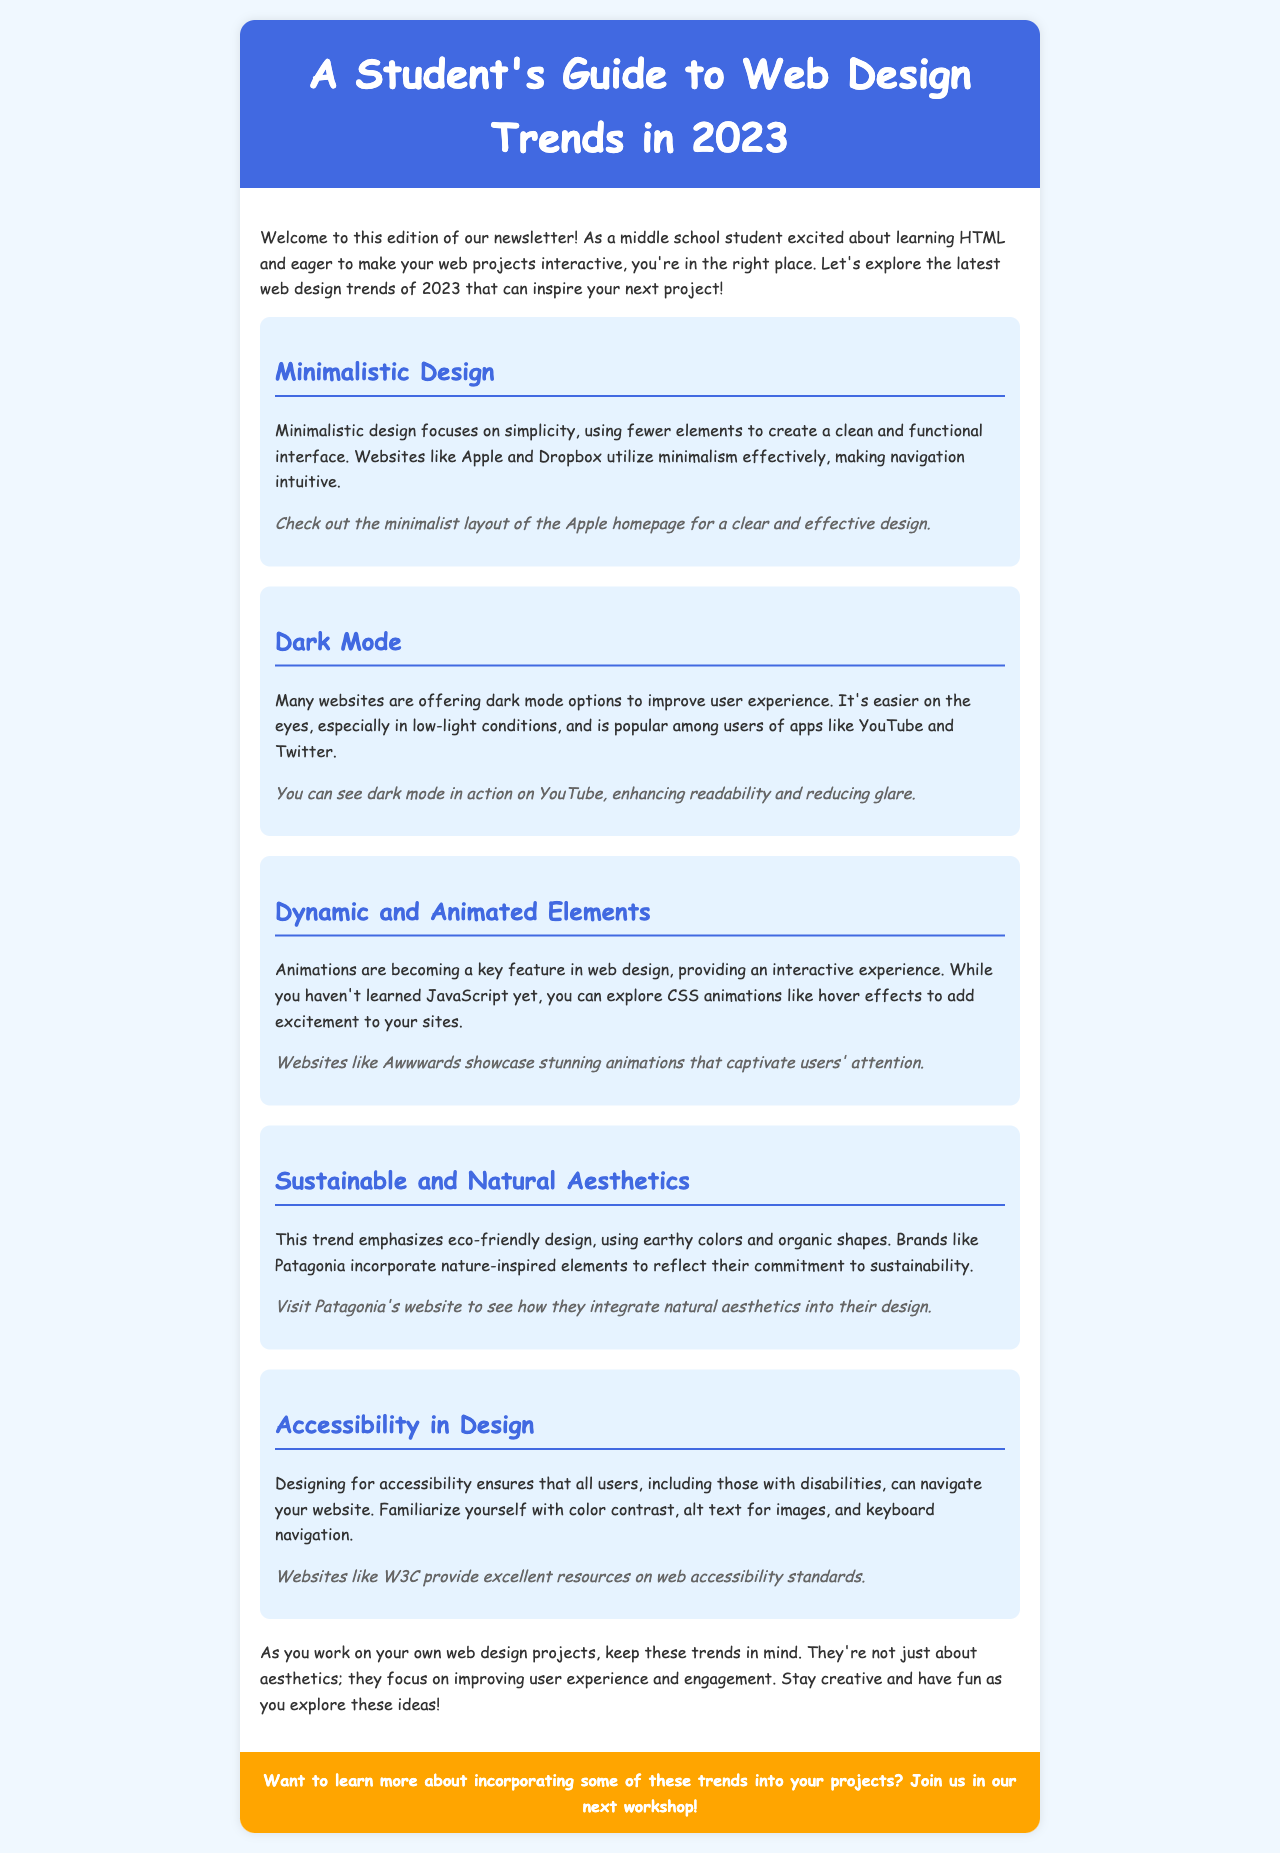What is the title of the newsletter? The title is mentioned in the `<title>` tag of the document.
Answer: A Student's Guide to Web Design Trends in 2023 What is one example of a website that uses minimalistic design? The document provides specific examples of websites that embody the trend discussed.
Answer: Apple What color is used for the header background? The specific color of the header background is detailed in the CSS style section.
Answer: #4169e1 Which design trend focuses on eco-friendly aesthetics? The document mentions a specific trend that emphasizes natural elements and sustainability.
Answer: Sustainable and Natural Aesthetics What is one way to enhance user experience according to the trends? The document mentions specific design trends that improve user interaction or accessibility.
Answer: Accessibility in Design Which social media platform is mentioned as using dark mode? The document provides a list of platforms that offer the dark mode feature.
Answer: Twitter What kind of animations can you explore without JavaScript? The document suggests a type of animation that can be implemented without needing to know JavaScript.
Answer: CSS animations What color is used for the call to action section? The color used for the background of the call to action is defined in the CSS style.
Answer: #ffa500 